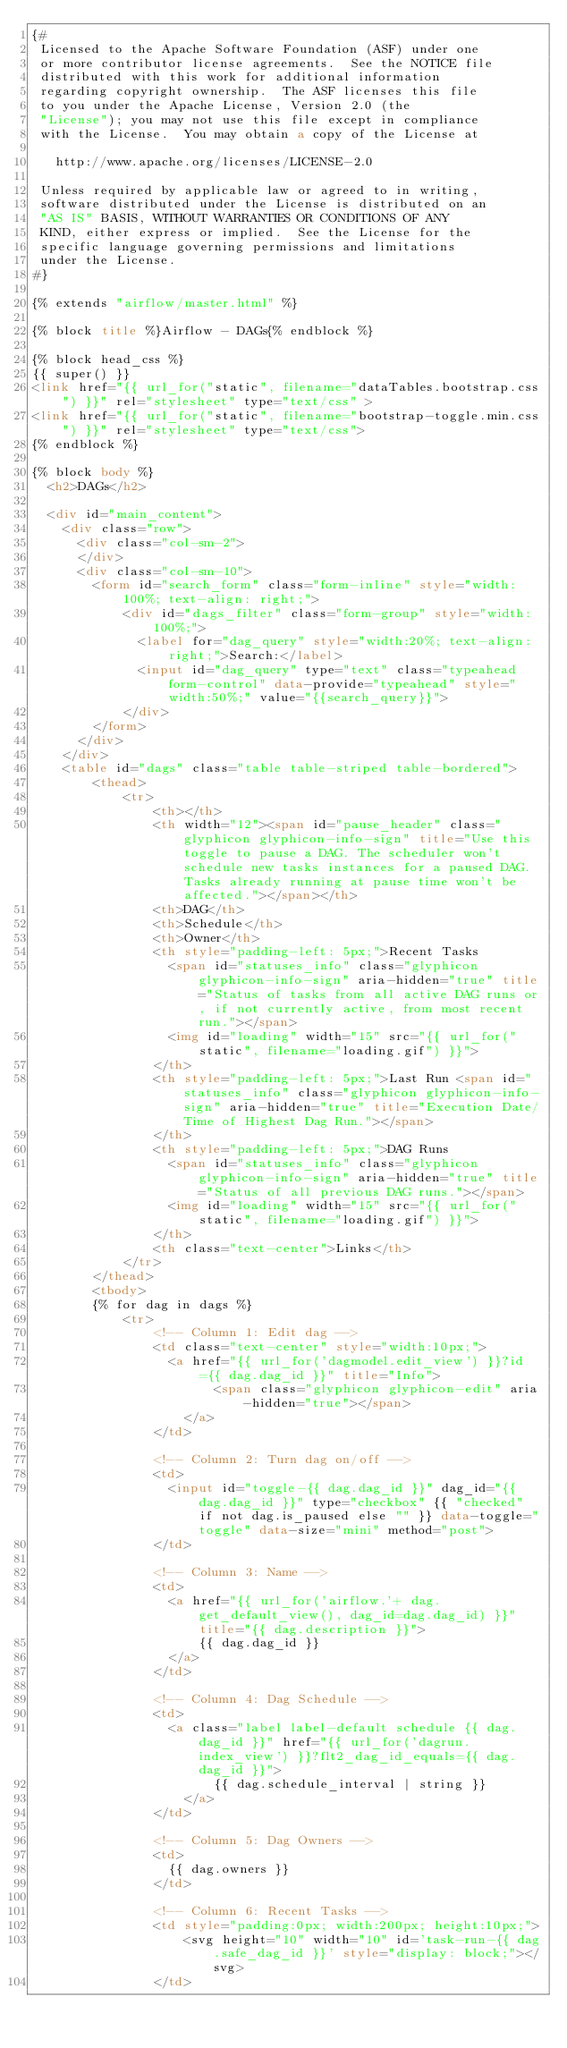<code> <loc_0><loc_0><loc_500><loc_500><_HTML_>{#
 Licensed to the Apache Software Foundation (ASF) under one
 or more contributor license agreements.  See the NOTICE file
 distributed with this work for additional information
 regarding copyright ownership.  The ASF licenses this file
 to you under the Apache License, Version 2.0 (the
 "License"); you may not use this file except in compliance
 with the License.  You may obtain a copy of the License at

   http://www.apache.org/licenses/LICENSE-2.0

 Unless required by applicable law or agreed to in writing,
 software distributed under the License is distributed on an
 "AS IS" BASIS, WITHOUT WARRANTIES OR CONDITIONS OF ANY
 KIND, either express or implied.  See the License for the
 specific language governing permissions and limitations
 under the License.
#}

{% extends "airflow/master.html" %}

{% block title %}Airflow - DAGs{% endblock %}

{% block head_css %}
{{ super() }}
<link href="{{ url_for("static", filename="dataTables.bootstrap.css") }}" rel="stylesheet" type="text/css" >
<link href="{{ url_for("static", filename="bootstrap-toggle.min.css") }}" rel="stylesheet" type="text/css">
{% endblock %}

{% block body %}
  <h2>DAGs</h2>

  <div id="main_content">
    <div class="row">
      <div class="col-sm-2">
      </div>
      <div class="col-sm-10">
        <form id="search_form" class="form-inline" style="width: 100%; text-align: right;">
            <div id="dags_filter" class="form-group" style="width: 100%;">
              <label for="dag_query" style="width:20%; text-align: right;">Search:</label>
              <input id="dag_query" type="text" class="typeahead form-control" data-provide="typeahead" style="width:50%;" value="{{search_query}}">
            </div>
        </form>
      </div>
    </div>
    <table id="dags" class="table table-striped table-bordered">
        <thead>
            <tr>
                <th></th>
                <th width="12"><span id="pause_header" class="glyphicon glyphicon-info-sign" title="Use this toggle to pause a DAG. The scheduler won't schedule new tasks instances for a paused DAG. Tasks already running at pause time won't be affected."></span></th>
                <th>DAG</th>
                <th>Schedule</th>
                <th>Owner</th>
                <th style="padding-left: 5px;">Recent Tasks
                  <span id="statuses_info" class="glyphicon glyphicon-info-sign" aria-hidden="true" title="Status of tasks from all active DAG runs or, if not currently active, from most recent run."></span>
                  <img id="loading" width="15" src="{{ url_for("static", filename="loading.gif") }}">
                </th>
                <th style="padding-left: 5px;">Last Run <span id="statuses_info" class="glyphicon glyphicon-info-sign" aria-hidden="true" title="Execution Date/Time of Highest Dag Run."></span>
                </th>
                <th style="padding-left: 5px;">DAG Runs
                  <span id="statuses_info" class="glyphicon glyphicon-info-sign" aria-hidden="true" title="Status of all previous DAG runs."></span>
                  <img id="loading" width="15" src="{{ url_for("static", filename="loading.gif") }}">
                </th>
                <th class="text-center">Links</th>
            </tr>
        </thead>
        <tbody>
        {% for dag in dags %}
            <tr>
                <!-- Column 1: Edit dag -->
                <td class="text-center" style="width:10px;">
                  <a href="{{ url_for('dagmodel.edit_view') }}?id={{ dag.dag_id }}" title="Info">
                        <span class="glyphicon glyphicon-edit" aria-hidden="true"></span>
                    </a>
                </td>

                <!-- Column 2: Turn dag on/off -->
                <td>
                  <input id="toggle-{{ dag.dag_id }}" dag_id="{{ dag.dag_id }}" type="checkbox" {{ "checked" if not dag.is_paused else "" }} data-toggle="toggle" data-size="mini" method="post">
                </td>

                <!-- Column 3: Name -->
                <td>
                  <a href="{{ url_for('airflow.'+ dag.get_default_view(), dag_id=dag.dag_id) }}" title="{{ dag.description }}">
                      {{ dag.dag_id }}
                  </a>
                </td>

                <!-- Column 4: Dag Schedule -->
                <td>
                  <a class="label label-default schedule {{ dag.dag_id }}" href="{{ url_for('dagrun.index_view') }}?flt2_dag_id_equals={{ dag.dag_id }}">
                        {{ dag.schedule_interval | string }}
                    </a>
                </td>

                <!-- Column 5: Dag Owners -->
                <td>
                  {{ dag.owners }}
                </td>

                <!-- Column 6: Recent Tasks -->
                <td style="padding:0px; width:200px; height:10px;">
                    <svg height="10" width="10" id='task-run-{{ dag.safe_dag_id }}' style="display: block;"></svg>
                </td>
</code> 